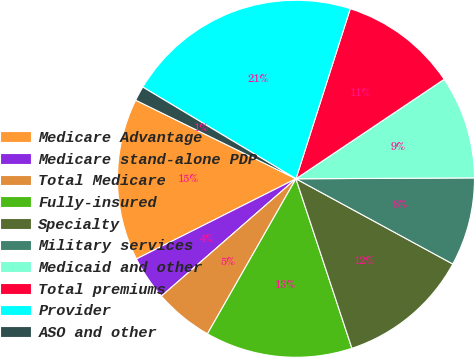Convert chart. <chart><loc_0><loc_0><loc_500><loc_500><pie_chart><fcel>Medicare Advantage<fcel>Medicare stand-alone PDP<fcel>Total Medicare<fcel>Fully-insured<fcel>Specialty<fcel>Military services<fcel>Medicaid and other<fcel>Total premiums<fcel>Provider<fcel>ASO and other<nl><fcel>14.67%<fcel>4.0%<fcel>5.33%<fcel>13.33%<fcel>12.0%<fcel>8.0%<fcel>9.33%<fcel>10.67%<fcel>21.33%<fcel>1.33%<nl></chart> 